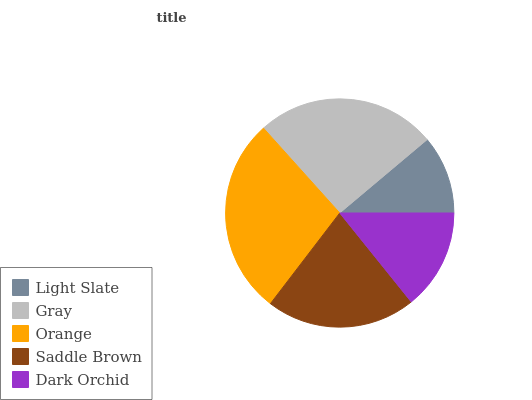Is Light Slate the minimum?
Answer yes or no. Yes. Is Orange the maximum?
Answer yes or no. Yes. Is Gray the minimum?
Answer yes or no. No. Is Gray the maximum?
Answer yes or no. No. Is Gray greater than Light Slate?
Answer yes or no. Yes. Is Light Slate less than Gray?
Answer yes or no. Yes. Is Light Slate greater than Gray?
Answer yes or no. No. Is Gray less than Light Slate?
Answer yes or no. No. Is Saddle Brown the high median?
Answer yes or no. Yes. Is Saddle Brown the low median?
Answer yes or no. Yes. Is Dark Orchid the high median?
Answer yes or no. No. Is Dark Orchid the low median?
Answer yes or no. No. 